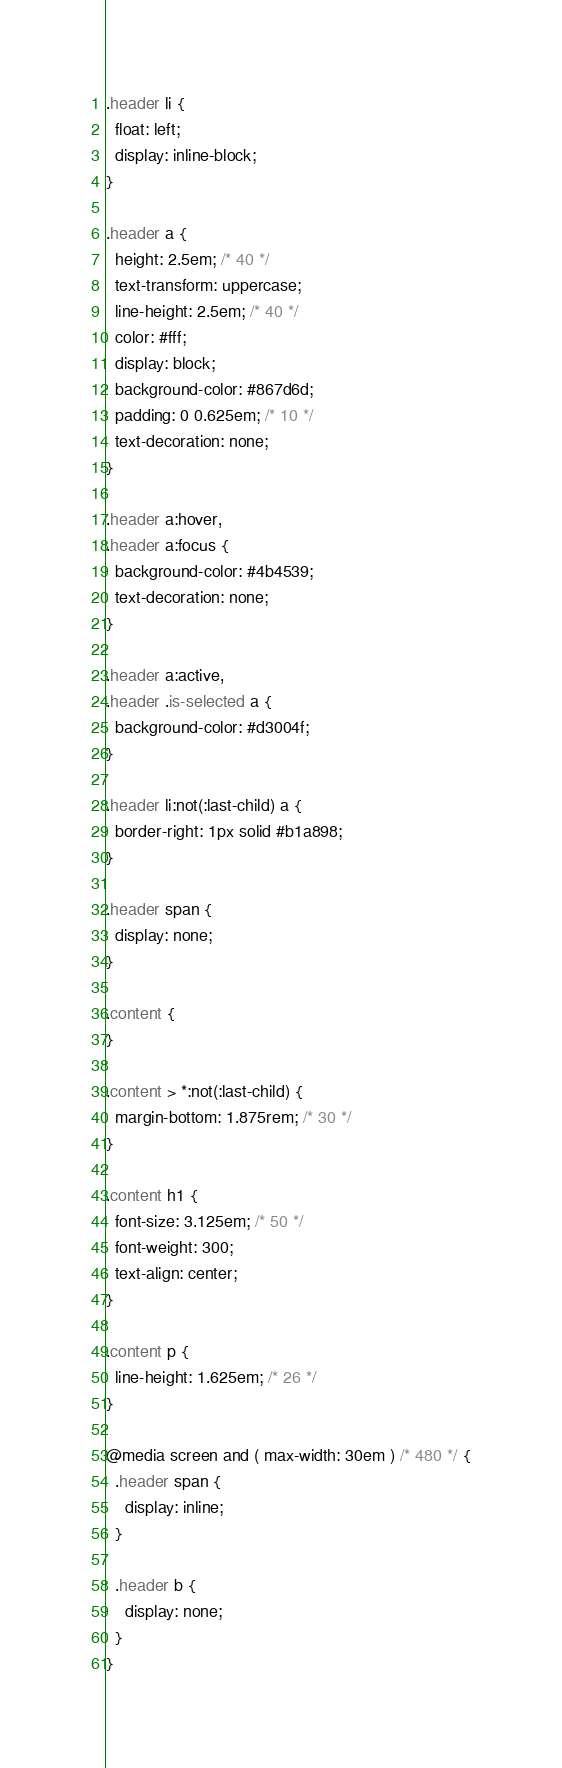Convert code to text. <code><loc_0><loc_0><loc_500><loc_500><_CSS_>
.header li {
  float: left;
  display: inline-block;
}

.header a {
  height: 2.5em; /* 40 */
  text-transform: uppercase;
  line-height: 2.5em; /* 40 */
  color: #fff;
  display: block;
  background-color: #867d6d;
  padding: 0 0.625em; /* 10 */
  text-decoration: none;
}

.header a:hover,
.header a:focus {
  background-color: #4b4539;
  text-decoration: none;
}

.header a:active,
.header .is-selected a {
  background-color: #d3004f;
}

.header li:not(:last-child) a {
  border-right: 1px solid #b1a898;
}

.header span {
  display: none;
}

.content {
}

.content > *:not(:last-child) {
  margin-bottom: 1.875rem; /* 30 */
}

.content h1 {
  font-size: 3.125em; /* 50 */
  font-weight: 300;
  text-align: center;
}

.content p {
  line-height: 1.625em; /* 26 */
}

@media screen and ( max-width: 30em ) /* 480 */ {
  .header span {
    display: inline;
  }

  .header b {
    display: none;
  }
}
</code> 